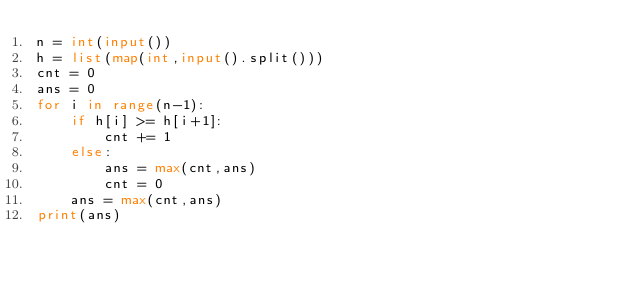<code> <loc_0><loc_0><loc_500><loc_500><_Python_>n = int(input())
h = list(map(int,input().split()))
cnt = 0
ans = 0
for i in range(n-1):
    if h[i] >= h[i+1]:
        cnt += 1
    else:
        ans = max(cnt,ans)
        cnt = 0
    ans = max(cnt,ans)
print(ans)</code> 